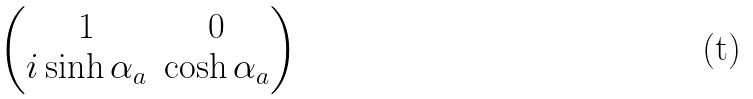<formula> <loc_0><loc_0><loc_500><loc_500>\begin{pmatrix} 1 & 0 \\ i \sinh \alpha _ { a } & \cosh \alpha _ { a } \end{pmatrix}</formula> 